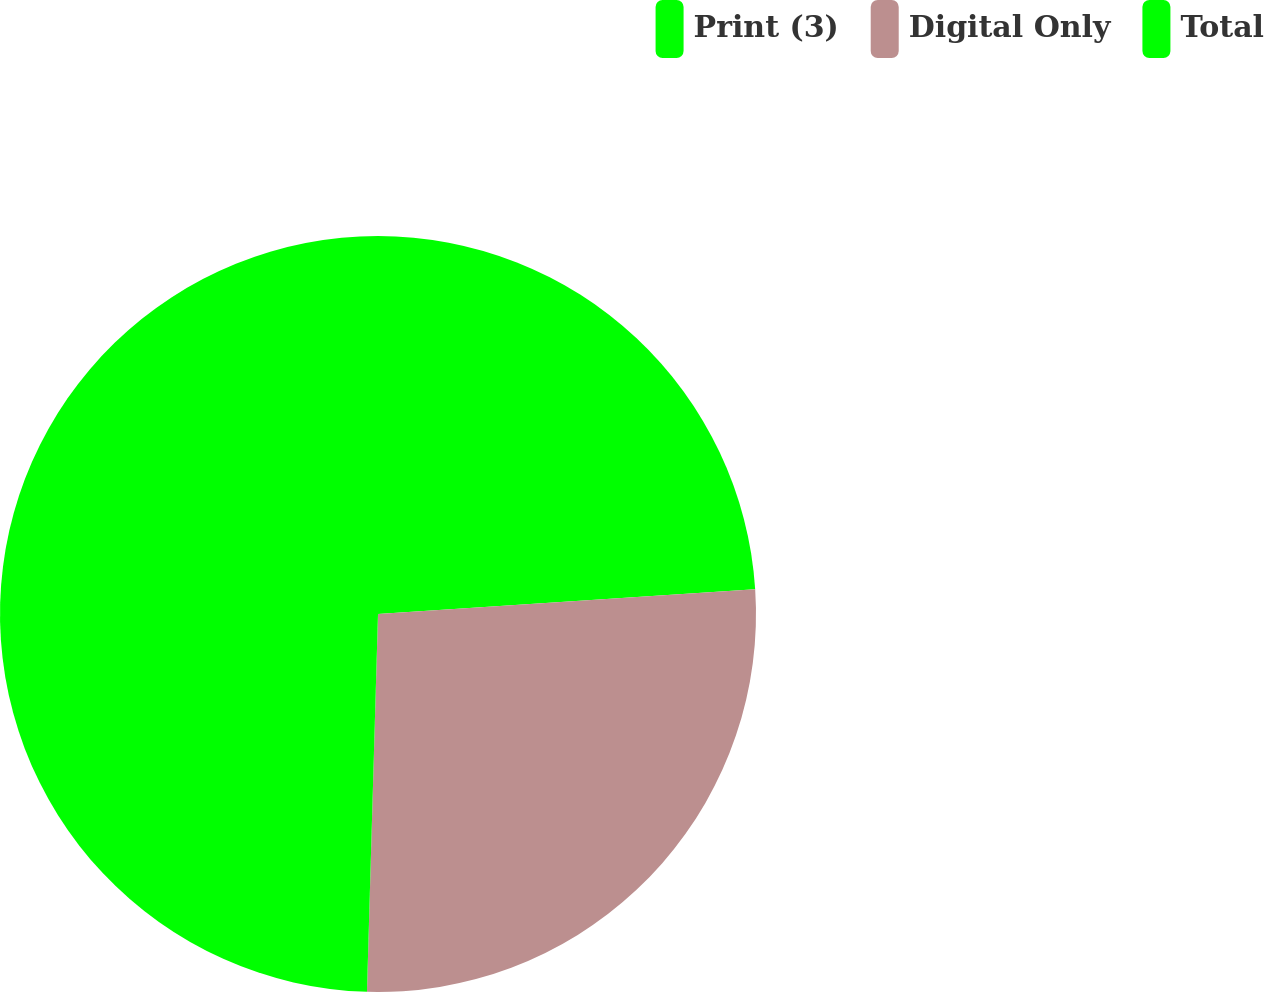Convert chart. <chart><loc_0><loc_0><loc_500><loc_500><pie_chart><fcel>Print (3)<fcel>Digital Only<fcel>Total<nl><fcel>23.95%<fcel>26.51%<fcel>49.53%<nl></chart> 